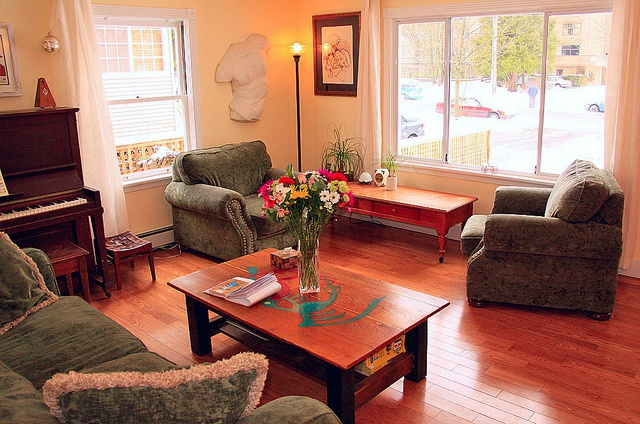Describe the objects in this image and their specific colors. I can see couch in tan, gray, black, maroon, and brown tones, couch in tan, black, maroon, lightgray, and gray tones, chair in tan, black, maroon, lightgray, and gray tones, chair in tan, maroon, black, and gray tones, and couch in tan, maroon, black, and gray tones in this image. 